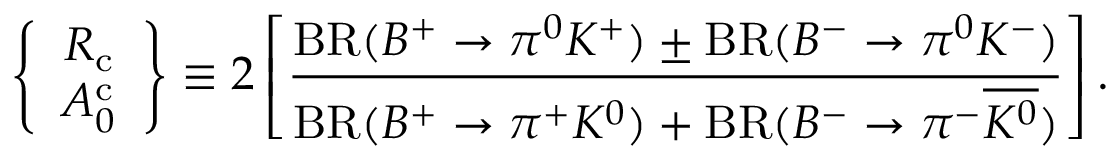<formula> <loc_0><loc_0><loc_500><loc_500>\left \{ \begin{array} { c } { { R _ { c } } } \\ { { A _ { 0 } ^ { c } } } \end{array} \right \} \equiv 2 \left [ \frac { B R ( B ^ { + } \to \pi ^ { 0 } K ^ { + } ) \pm B R ( B ^ { - } \to \pi ^ { 0 } K ^ { - } ) } { B R ( B ^ { + } \to \pi ^ { + } K ^ { 0 } ) + B R ( B ^ { - } \to \pi ^ { - } \overline { { { K ^ { 0 } } } } ) } \right ] .</formula> 